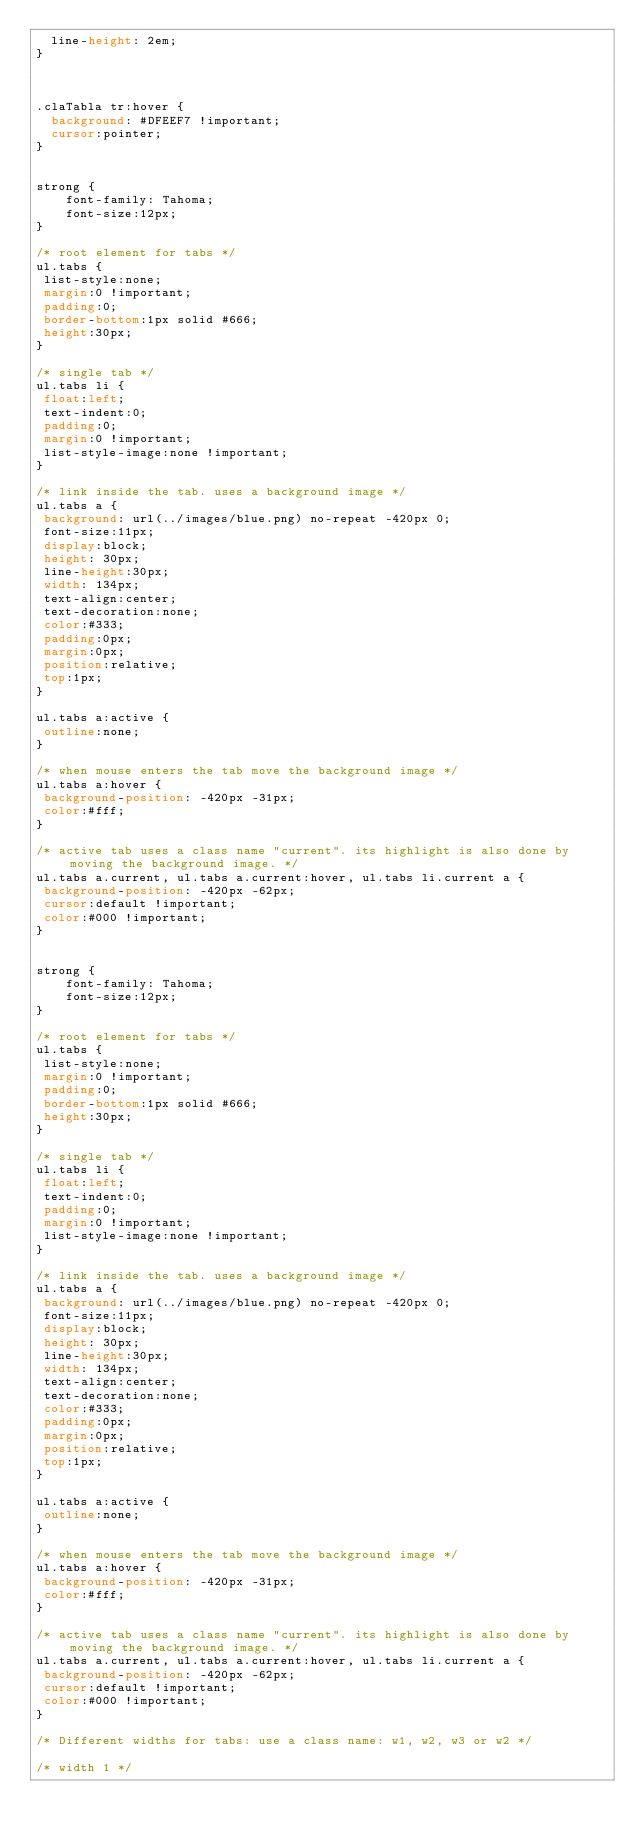Convert code to text. <code><loc_0><loc_0><loc_500><loc_500><_CSS_>  line-height: 2em;
}

 

.claTabla tr:hover {
  background: #DFEEF7 !important;
  cursor:pointer;
}


strong {
    font-family: Tahoma;
	font-size:12px;
}

/* root element for tabs */
ul.tabs {
 list-style:none;
 margin:0 !important;
 padding:0;
 border-bottom:1px solid #666;
 height:30px;
}

/* single tab */
ul.tabs li {
 float:left;
 text-indent:0;
 padding:0;
 margin:0 !important;
 list-style-image:none !important;
}

/* link inside the tab. uses a background image */
ul.tabs a {
 background: url(../images/blue.png) no-repeat -420px 0;
 font-size:11px;
 display:block;
 height: 30px;
 line-height:30px;
 width: 134px;
 text-align:center;
 text-decoration:none;
 color:#333;
 padding:0px;
 margin:0px;
 position:relative;
 top:1px;
}

ul.tabs a:active {
 outline:none;
}

/* when mouse enters the tab move the background image */
ul.tabs a:hover {
 background-position: -420px -31px;
 color:#fff;
}

/* active tab uses a class name "current". its highlight is also done by moving the background image. */
ul.tabs a.current, ul.tabs a.current:hover, ul.tabs li.current a {
 background-position: -420px -62px;
 cursor:default !important;
 color:#000 !important;
}


strong {
    font-family: Tahoma;
	font-size:12px;
}

/* root element for tabs */
ul.tabs {
 list-style:none;
 margin:0 !important;
 padding:0;
 border-bottom:1px solid #666;
 height:30px;
}

/* single tab */
ul.tabs li {
 float:left;
 text-indent:0;
 padding:0;
 margin:0 !important;
 list-style-image:none !important;
}

/* link inside the tab. uses a background image */
ul.tabs a {
 background: url(../images/blue.png) no-repeat -420px 0;
 font-size:11px;
 display:block;
 height: 30px;
 line-height:30px;
 width: 134px;
 text-align:center;
 text-decoration:none;
 color:#333;
 padding:0px;
 margin:0px;
 position:relative;
 top:1px;
}

ul.tabs a:active {
 outline:none;
}

/* when mouse enters the tab move the background image */
ul.tabs a:hover {
 background-position: -420px -31px;
 color:#fff;
}

/* active tab uses a class name "current". its highlight is also done by moving the background image. */
ul.tabs a.current, ul.tabs a.current:hover, ul.tabs li.current a {
 background-position: -420px -62px;
 cursor:default !important;
 color:#000 !important;
}

/* Different widths for tabs: use a class name: w1, w2, w3 or w2 */

/* width 1 */</code> 